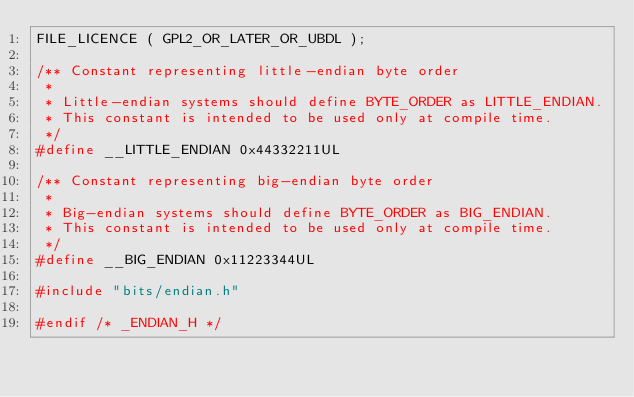Convert code to text. <code><loc_0><loc_0><loc_500><loc_500><_C_>FILE_LICENCE ( GPL2_OR_LATER_OR_UBDL );

/** Constant representing little-endian byte order
 *
 * Little-endian systems should define BYTE_ORDER as LITTLE_ENDIAN.
 * This constant is intended to be used only at compile time.
 */
#define __LITTLE_ENDIAN 0x44332211UL

/** Constant representing big-endian byte order
 *
 * Big-endian systems should define BYTE_ORDER as BIG_ENDIAN.
 * This constant is intended to be used only at compile time.
 */
#define __BIG_ENDIAN 0x11223344UL

#include "bits/endian.h"

#endif /* _ENDIAN_H */
</code> 